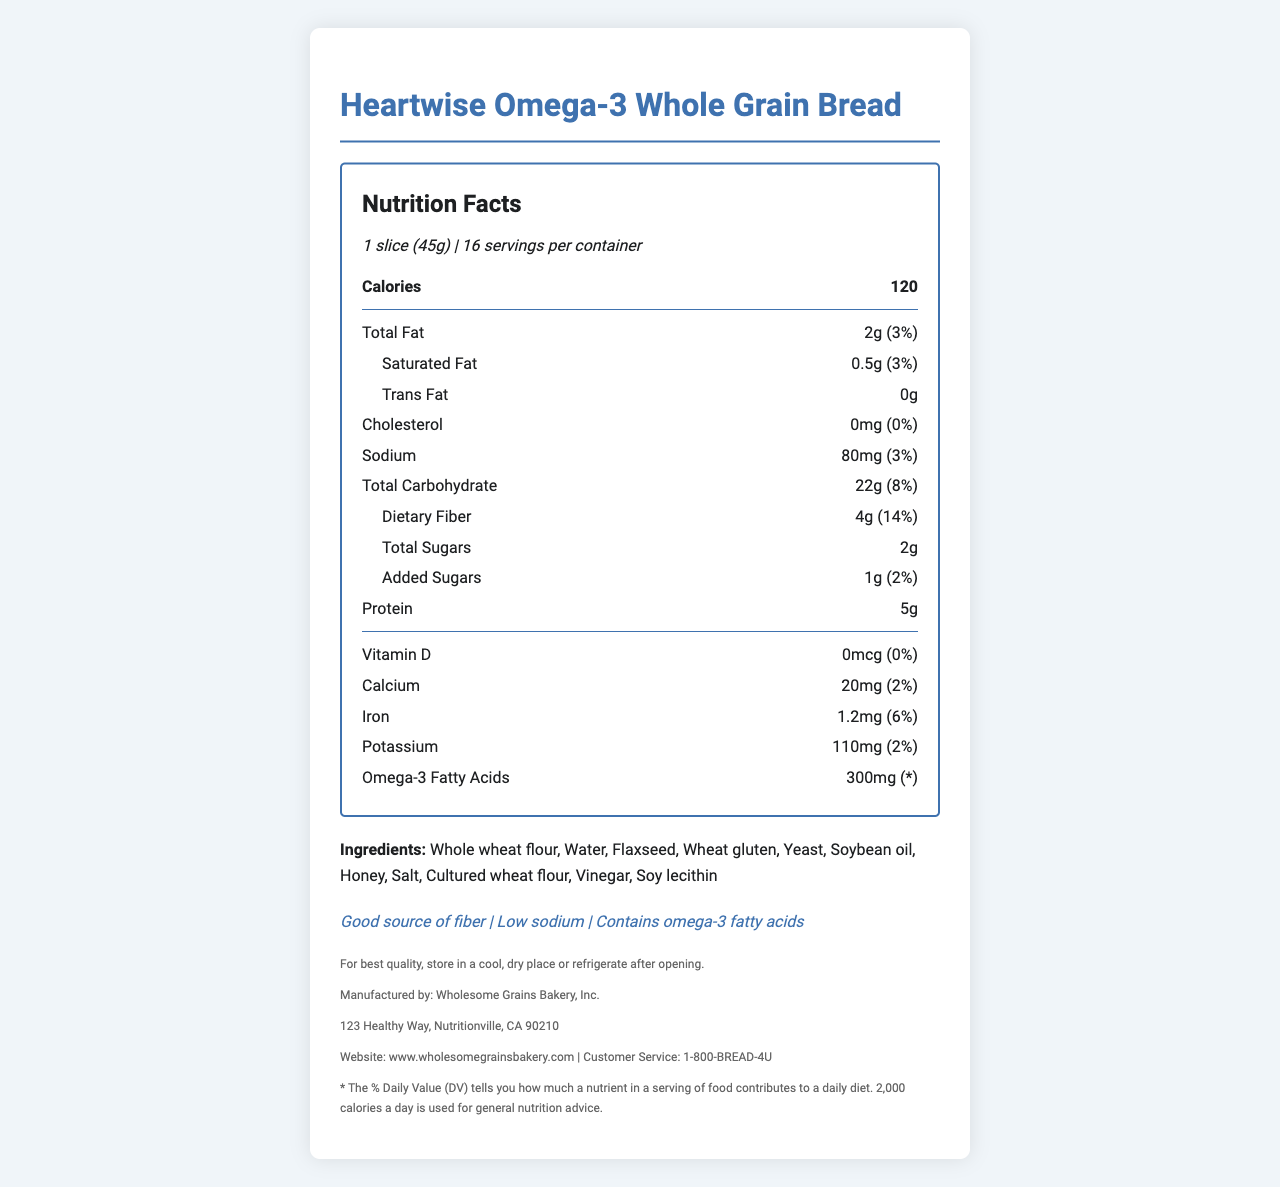what is the serving size? The serving size is specified in the document as 1 slice (45g).
Answer: 1 slice (45g) how many servings are there per container? The document mentions that there are 16 servings per container.
Answer: 16 how many calories are there per serving? The document lists the calorie content as 120 per serving.
Answer: 120 how much dietary fiber does one serving provide? The document states that one serving contains 4g of dietary fiber.
Answer: 4g what is the amount of saturated fat per serving? The saturated fat content per serving is listed as 0.5g in the document.
Answer: 0.5g how much sodium does one serving contain and what percentage of the daily value is this? According to the document, one serving contains 80mg of sodium, which is 3% of the daily value.
Answer: 80mg, 3% what are the ingredients in the bread? The document provides a list of the ingredients used in the bread.
Answer: Whole wheat flour, Water, Flaxseed, Wheat gluten, Yeast, Soybean oil, Honey, Salt, Cultured wheat flour, Vinegar, Soy lecithin which nutrients have 0% of the daily value as per the document? A. Vitamin D and Cholesterol B. Iron and Vitamin D C. Calcium and Vitamin D D. Potassium and Iron The document indicates that both Vitamin D and Cholesterol have 0% of the daily value.
Answer: A. Vitamin D and Cholesterol how much omega-3 fatty acids does one serving of bread contain? A. 200mg B. 300mg C. 400mg D. 500mg The document states that one serving of bread contains 300mg of omega-3 fatty acids.
Answer: B. 300mg is the bread low in sodium? The document specifically states that the bread is a low-sodium product.
Answer: Yes describe the primary health benefits claimed by the product. The document lists these specific health benefits as claims associated with the product.
Answer: The product claims to be a good source of fiber, low in sodium, and contains omega-3 fatty acids. is the amount of protein in this bread higher or lower than 10 grams per serving? The document indicates that the bread contains 5g of protein per serving, which is lower than 10 grams.
Answer: Lower does the document specify how to store the bread once opened? Storage instructions are provided in the document, suggesting to store it in a cool, dry place or refrigerate after opening.
Answer: Yes, the document advises storing in a cool, dry place or refrigerating after opening. where is the bread manufactured? The document indicates that the manufacturer is located in Nutritionville, CA, as part of the manufacturer's address.
Answer: Nutritionville, CA what is the total amount of sugars per serving in the bread? The document states that the total sugars per serving is 2g.
Answer: 2g what is the phone number for customer service? The document lists the customer service phone number as 1-800-BREAD-4U.
Answer: 1-800-BREAD-4U how does this food contribute to daily dietary fiber according to the % daily value? The document states that the dietary fiber in the bread contributes 14% to the daily value.
Answer: 14% how much iron does one serving provide in terms of daily value percentage? The document mentions that one serving provides 6% of the daily value of iron.
Answer: 6% what type of oil is used in the bread ingredients? According to the ingredients list, soybean oil is used in the bread.
Answer: Soybean oil who is the manufacturer of this bread? The document states the manufacturer as Wholesome Grains Bakery, Inc.
Answer: Wholesome Grains Bakery, Inc. does the bread contain any allergens? The document lists wheat and soy as allergens present in the bread.
Answer: Yes, it contains wheat and soy. how does the nutrient composition of Heartwise Omega-3 Whole Grain Bread support a healthy diet? The document highlights that the bread is a good source of fiber, low in sodium, and provides omega-3 fatty acids, contributing to a healthy diet.
Answer: The bread is low in sodium, high in fiber, and contains omega-3 fatty acids, which are beneficial for heart health. what are the potassium levels in one serving? The document lists the potassium content as 110mg per serving.
Answer: 110mg is this bread gluten-free? The document does not state whether the bread is gluten-free, although it does list wheat gluten as an ingredient.
Answer: Cannot be determined 